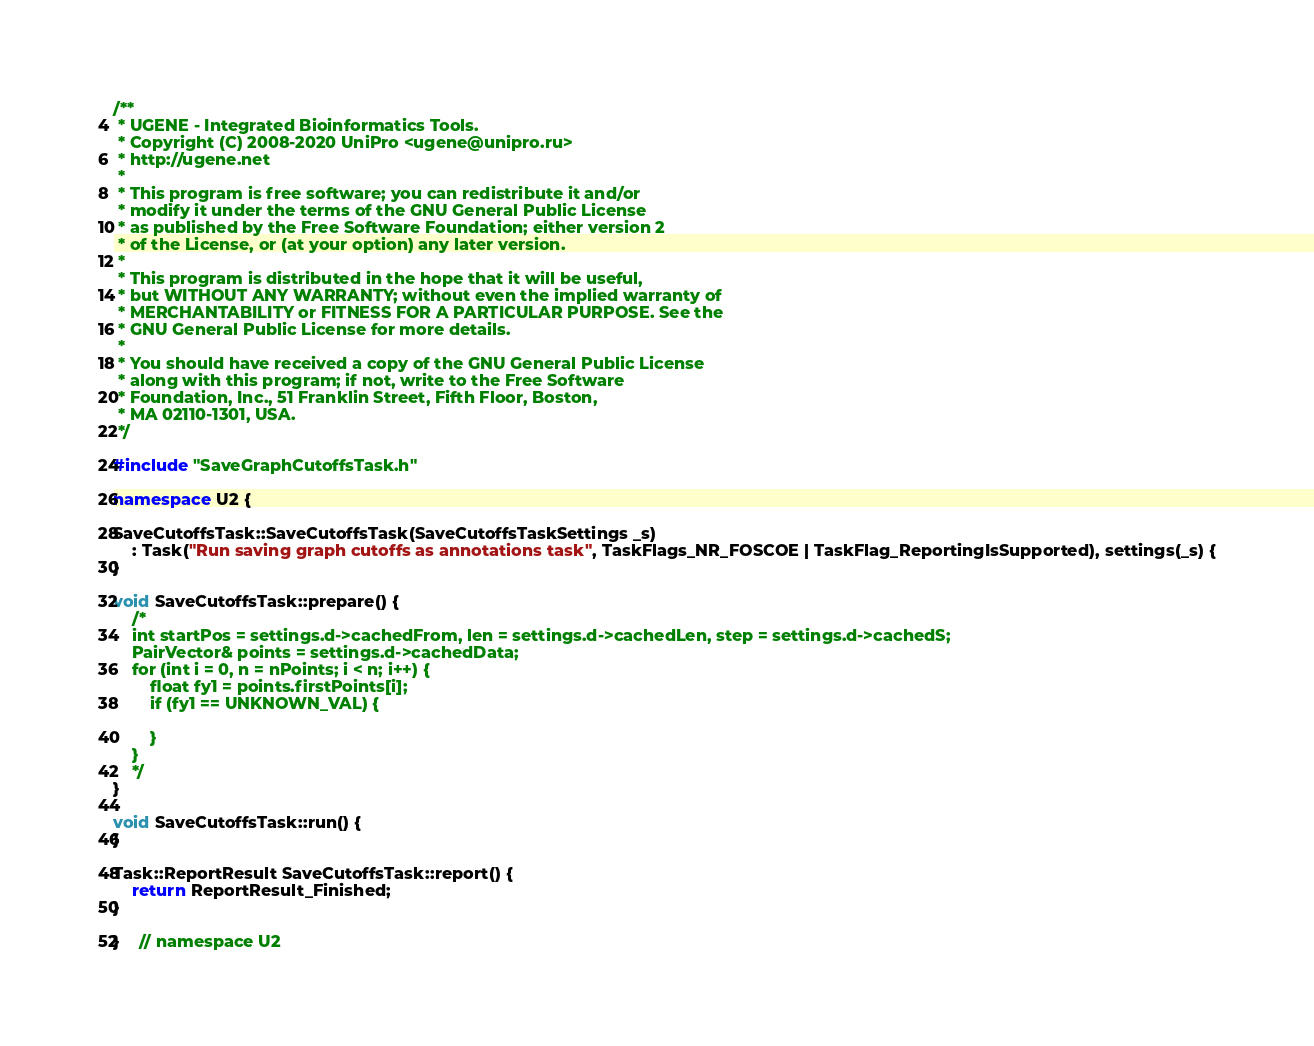Convert code to text. <code><loc_0><loc_0><loc_500><loc_500><_C++_>/**
 * UGENE - Integrated Bioinformatics Tools.
 * Copyright (C) 2008-2020 UniPro <ugene@unipro.ru>
 * http://ugene.net
 *
 * This program is free software; you can redistribute it and/or
 * modify it under the terms of the GNU General Public License
 * as published by the Free Software Foundation; either version 2
 * of the License, or (at your option) any later version.
 *
 * This program is distributed in the hope that it will be useful,
 * but WITHOUT ANY WARRANTY; without even the implied warranty of
 * MERCHANTABILITY or FITNESS FOR A PARTICULAR PURPOSE. See the
 * GNU General Public License for more details.
 *
 * You should have received a copy of the GNU General Public License
 * along with this program; if not, write to the Free Software
 * Foundation, Inc., 51 Franklin Street, Fifth Floor, Boston,
 * MA 02110-1301, USA.
 */

#include "SaveGraphCutoffsTask.h"

namespace U2 {

SaveCutoffsTask::SaveCutoffsTask(SaveCutoffsTaskSettings _s)
    : Task("Run saving graph cutoffs as annotations task", TaskFlags_NR_FOSCOE | TaskFlag_ReportingIsSupported), settings(_s) {
}

void SaveCutoffsTask::prepare() {
    /*
    int startPos = settings.d->cachedFrom, len = settings.d->cachedLen, step = settings.d->cachedS;
    PairVector& points = settings.d->cachedData;
    for (int i = 0, n = nPoints; i < n; i++) {
        float fy1 = points.firstPoints[i];
        if (fy1 == UNKNOWN_VAL) {

        }
    }
    */
}

void SaveCutoffsTask::run() {
}

Task::ReportResult SaveCutoffsTask::report() {
    return ReportResult_Finished;
}

}    // namespace U2
</code> 